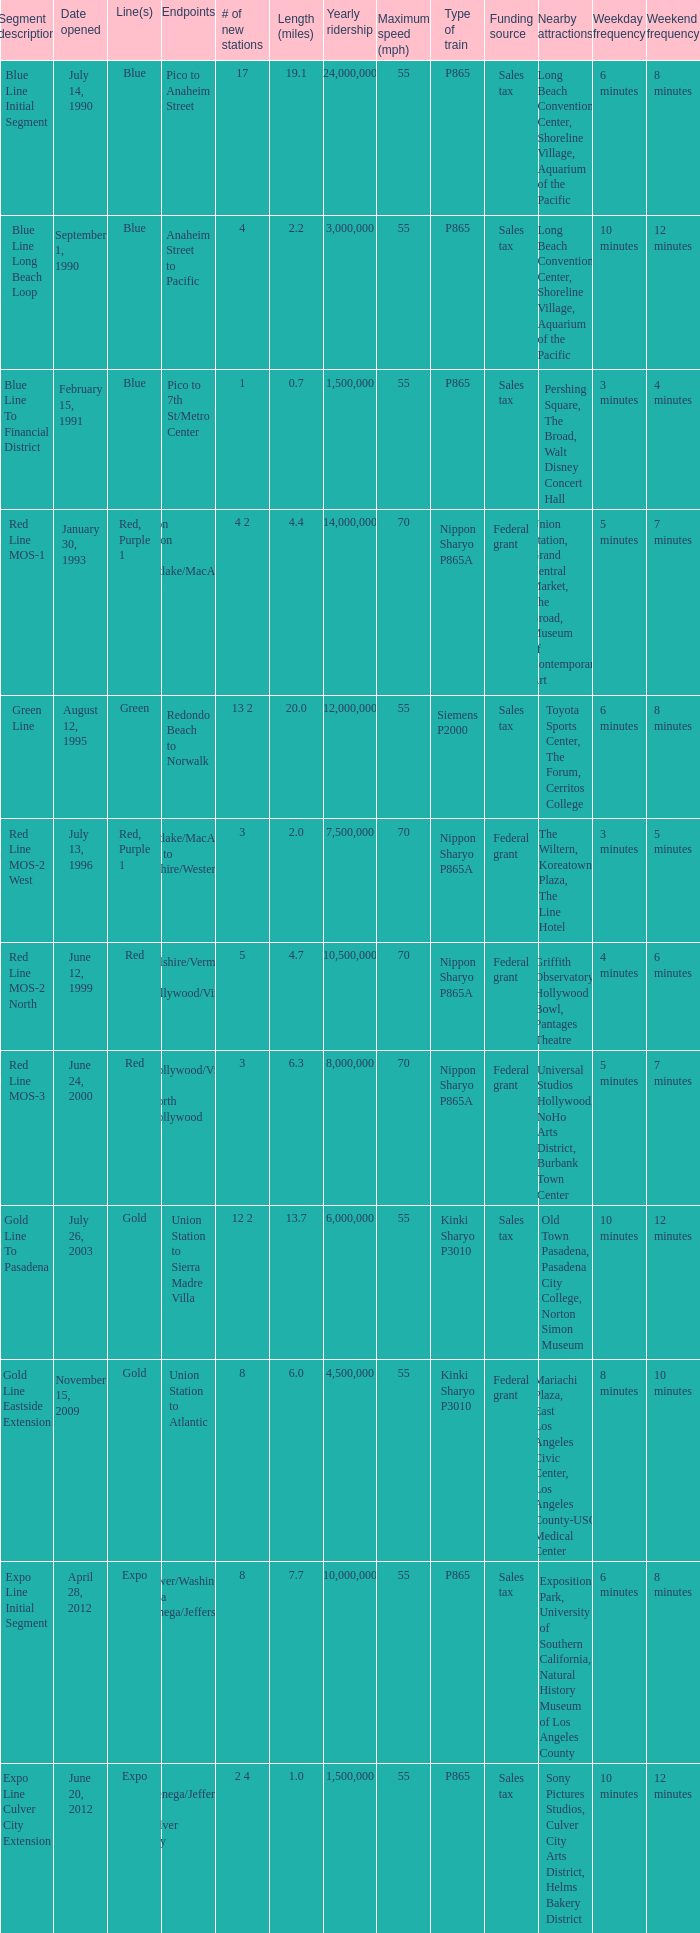Would you be able to parse every entry in this table? {'header': ['Segment description', 'Date opened', 'Line(s)', 'Endpoints', '# of new stations', 'Length (miles)', 'Yearly ridership', 'Maximum speed (mph)', 'Type of train', 'Funding source', 'Nearby attractions', 'Weekday frequency', 'Weekend frequency'], 'rows': [['Blue Line Initial Segment', 'July 14, 1990', 'Blue', 'Pico to Anaheim Street', '17', '19.1', '24,000,000', '55', 'P865', 'Sales tax', 'Long Beach Convention Center, Shoreline Village, Aquarium of the Pacific', '6 minutes', '8 minutes'], ['Blue Line Long Beach Loop', 'September 1, 1990', 'Blue', 'Anaheim Street to Pacific', '4', '2.2', '3,000,000', '55', 'P865', 'Sales tax', 'Long Beach Convention Center, Shoreline Village, Aquarium of the Pacific', '10 minutes', '12 minutes'], ['Blue Line To Financial District', 'February 15, 1991', 'Blue', 'Pico to 7th St/Metro Center', '1', '0.7', '1,500,000', '55', 'P865', 'Sales tax', 'Pershing Square, The Broad, Walt Disney Concert Hall', '3 minutes', '4 minutes'], ['Red Line MOS-1', 'January 30, 1993', 'Red, Purple 1', 'Union Station to Westlake/MacArthur Park', '4 2', '4.4', '14,000,000', '70', 'Nippon Sharyo P865A', 'Federal grant', 'Union Station, Grand Central Market, The Broad, Museum of Contemporary Art', '5 minutes', '7 minutes'], ['Green Line', 'August 12, 1995', 'Green', 'Redondo Beach to Norwalk', '13 2', '20.0', '12,000,000', '55', 'Siemens P2000', 'Sales tax', 'Toyota Sports Center, The Forum, Cerritos College', '6 minutes', '8 minutes'], ['Red Line MOS-2 West', 'July 13, 1996', 'Red, Purple 1', 'Westlake/MacArthur Park to Wilshire/Western', '3', '2.0', '7,500,000', '70', 'Nippon Sharyo P865A', 'Federal grant', 'The Wiltern, Koreatown Plaza, The Line Hotel', '3 minutes', '5 minutes'], ['Red Line MOS-2 North', 'June 12, 1999', 'Red', 'Wilshire/Vermont to Hollywood/Vine', '5', '4.7', '10,500,000', '70', 'Nippon Sharyo P865A', 'Federal grant', 'Griffith Observatory, Hollywood Bowl, Pantages Theatre', '4 minutes', '6 minutes'], ['Red Line MOS-3', 'June 24, 2000', 'Red', 'Hollywood/Vine to North Hollywood', '3', '6.3', '8,000,000', '70', 'Nippon Sharyo P865A', 'Federal grant', 'Universal Studios Hollywood, NoHo Arts District, Burbank Town Center', '5 minutes', '7 minutes'], ['Gold Line To Pasadena', 'July 26, 2003', 'Gold', 'Union Station to Sierra Madre Villa', '12 2', '13.7', '6,000,000', '55', 'Kinki Sharyo P3010', 'Sales tax', 'Old Town Pasadena, Pasadena City College, Norton Simon Museum', '10 minutes', '12 minutes'], ['Gold Line Eastside Extension', 'November 15, 2009', 'Gold', 'Union Station to Atlantic', '8', '6.0', '4,500,000', '55', 'Kinki Sharyo P3010', 'Federal grant', 'Mariachi Plaza, East Los Angeles Civic Center, Los Angeles County-USC Medical Center', '8 minutes', '10 minutes'], ['Expo Line Initial Segment', 'April 28, 2012', 'Expo', 'Flower/Washington to La Cienega/Jefferson 3', '8', '7.7', '10,000,000', '55', 'P865', 'Sales tax', 'Exposition Park, University of Southern California, Natural History Museum of Los Angeles County', '6 minutes', '8 minutes'], ['Expo Line Culver City Extension', 'June 20, 2012', 'Expo', 'La Cienega/Jefferson to Culver City', '2 4', '1.0', '1,500,000', '55', 'P865', 'Sales tax', 'Sony Pictures Studios, Culver City Arts District, Helms Bakery District', '10 minutes', '12 minutes']]} How many lines have the segment description of red line mos-2 west? Red, Purple 1. 